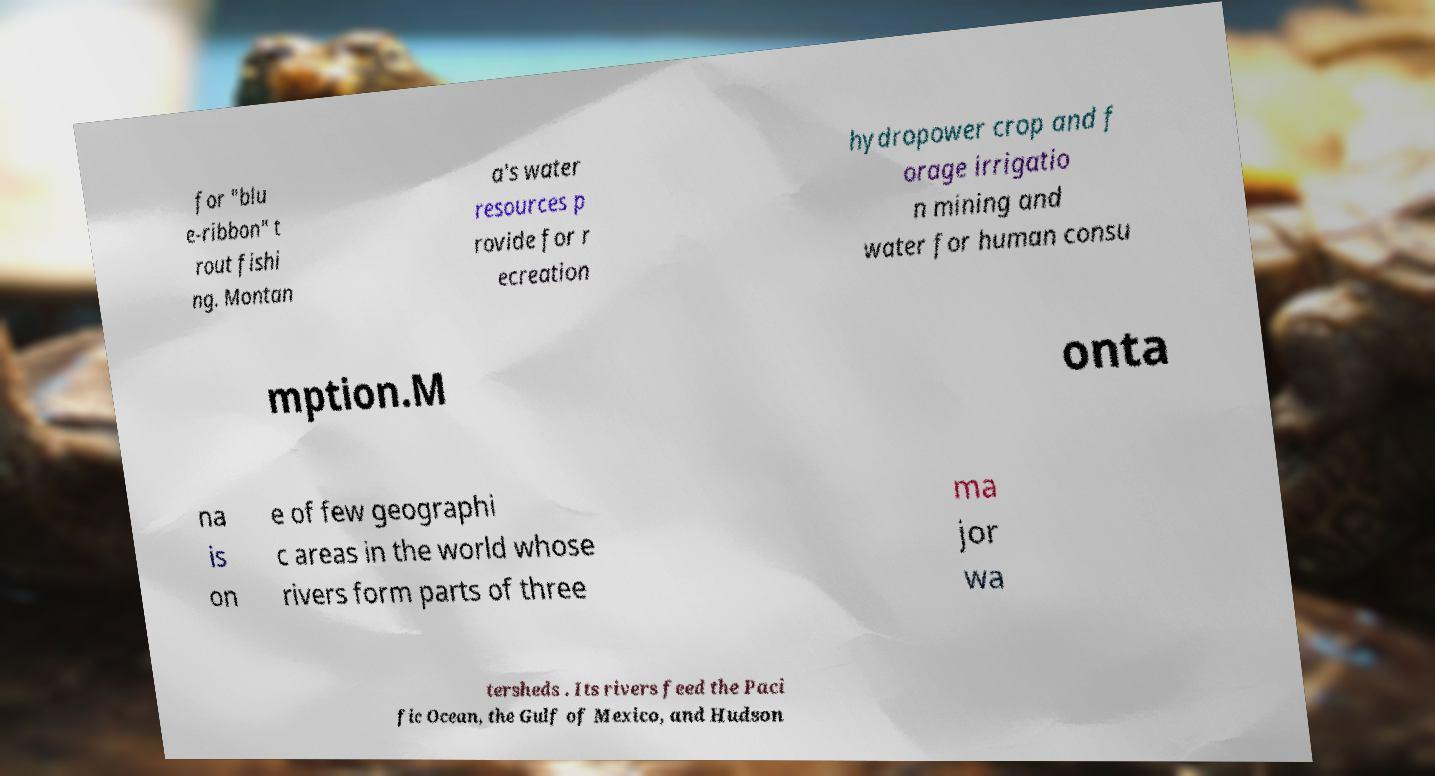Please read and relay the text visible in this image. What does it say? for "blu e-ribbon" t rout fishi ng. Montan a's water resources p rovide for r ecreation hydropower crop and f orage irrigatio n mining and water for human consu mption.M onta na is on e of few geographi c areas in the world whose rivers form parts of three ma jor wa tersheds . Its rivers feed the Paci fic Ocean, the Gulf of Mexico, and Hudson 